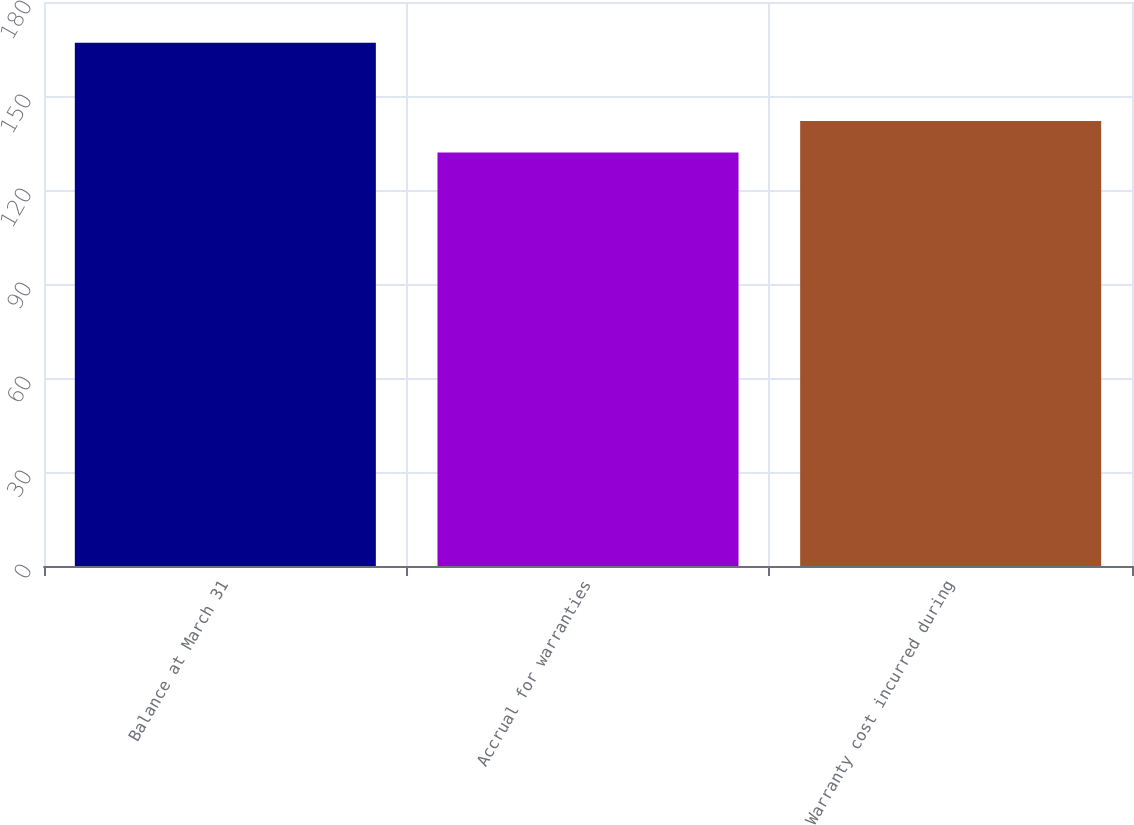<chart> <loc_0><loc_0><loc_500><loc_500><bar_chart><fcel>Balance at March 31<fcel>Accrual for warranties<fcel>Warranty cost incurred during<nl><fcel>167<fcel>132<fcel>142<nl></chart> 